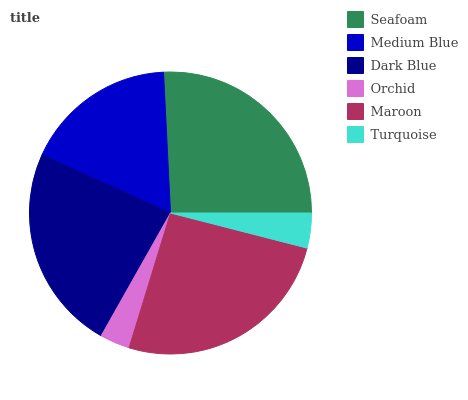Is Orchid the minimum?
Answer yes or no. Yes. Is Seafoam the maximum?
Answer yes or no. Yes. Is Medium Blue the minimum?
Answer yes or no. No. Is Medium Blue the maximum?
Answer yes or no. No. Is Seafoam greater than Medium Blue?
Answer yes or no. Yes. Is Medium Blue less than Seafoam?
Answer yes or no. Yes. Is Medium Blue greater than Seafoam?
Answer yes or no. No. Is Seafoam less than Medium Blue?
Answer yes or no. No. Is Dark Blue the high median?
Answer yes or no. Yes. Is Medium Blue the low median?
Answer yes or no. Yes. Is Medium Blue the high median?
Answer yes or no. No. Is Orchid the low median?
Answer yes or no. No. 